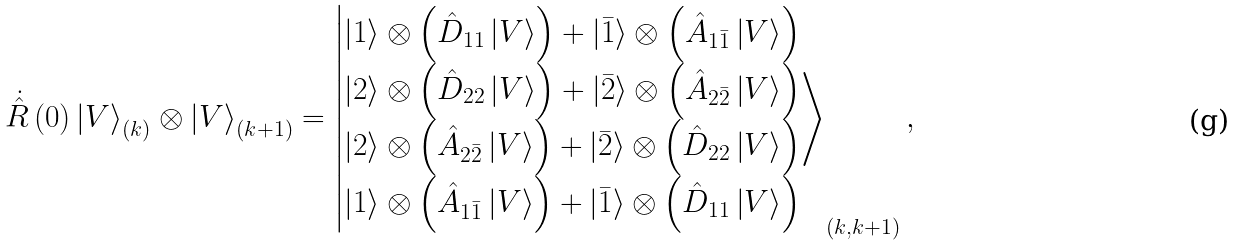<formula> <loc_0><loc_0><loc_500><loc_500>\dot { \hat { R } } \left ( 0 \right ) \left | V \right \rangle _ { ( k ) } \otimes \left | V \right \rangle _ { ( k + 1 ) } = \left | \begin{matrix} \left | 1 \right \rangle \otimes \left ( \hat { D } _ { 1 1 } \left | V \right \rangle \right ) + \left | \bar { 1 } \right \rangle \otimes \left ( \hat { A } _ { 1 \bar { 1 } } \left | V \right \rangle \right ) \\ \left | 2 \right \rangle \otimes \left ( \hat { D } _ { 2 2 } \left | V \right \rangle \right ) + \left | \bar { 2 } \right \rangle \otimes \left ( \hat { A } _ { 2 \bar { 2 } } \left | V \right \rangle \right ) \\ \left | 2 \right \rangle \otimes \left ( \hat { A } _ { 2 \bar { 2 } } \left | V \right \rangle \right ) + \left | \bar { 2 } \right \rangle \otimes \left ( \hat { D } _ { 2 2 } \left | V \right \rangle \right ) \\ \left | 1 \right \rangle \otimes \left ( \hat { A } _ { 1 \bar { 1 } } \left | V \right \rangle \right ) + \left | \bar { 1 } \right \rangle \otimes \left ( \hat { D } _ { 1 1 } \left | V \right \rangle \right ) \\ \end{matrix} \right \rangle _ { \left ( k , k + 1 \right ) } ,</formula> 